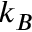<formula> <loc_0><loc_0><loc_500><loc_500>k _ { B }</formula> 